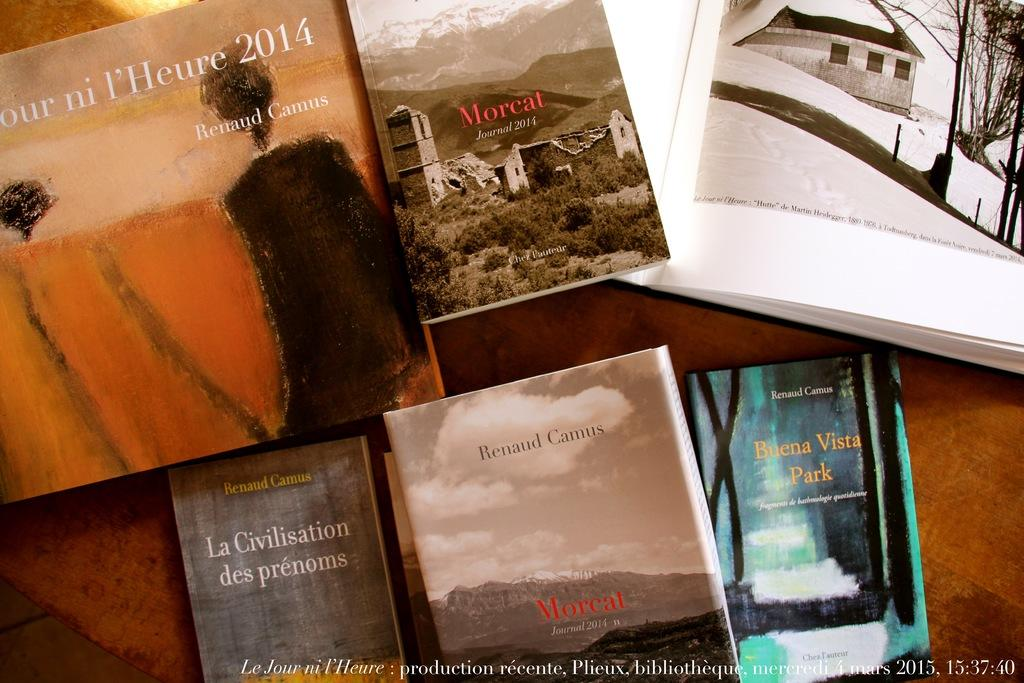<image>
Describe the image concisely. A variety of books by Renaud Camus including Buena Vista Park 